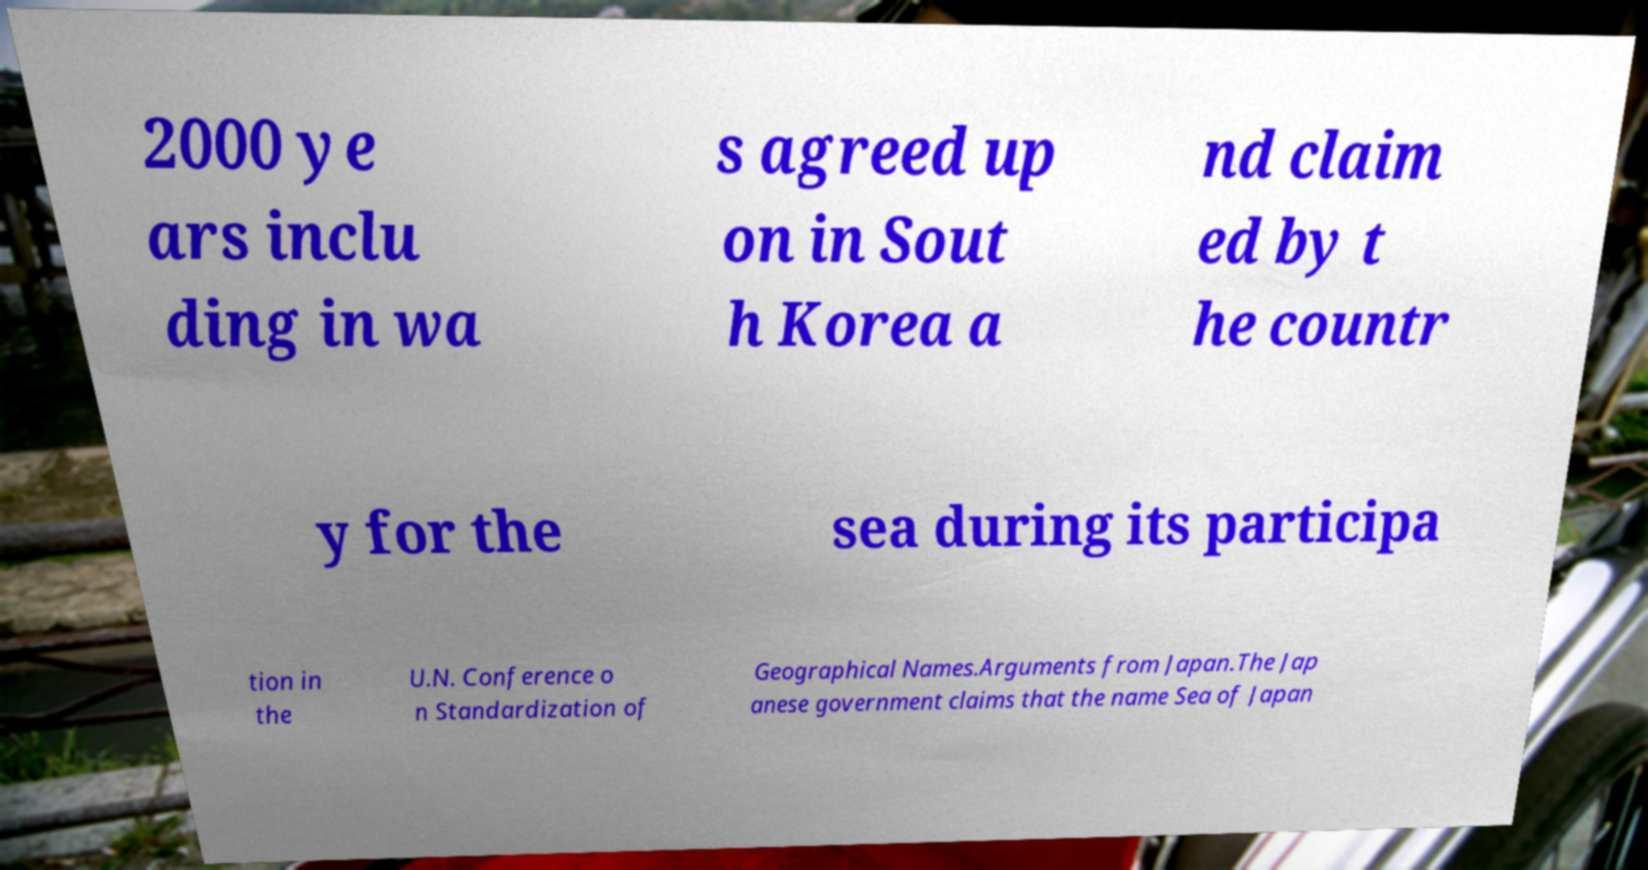Can you read and provide the text displayed in the image?This photo seems to have some interesting text. Can you extract and type it out for me? 2000 ye ars inclu ding in wa s agreed up on in Sout h Korea a nd claim ed by t he countr y for the sea during its participa tion in the U.N. Conference o n Standardization of Geographical Names.Arguments from Japan.The Jap anese government claims that the name Sea of Japan 